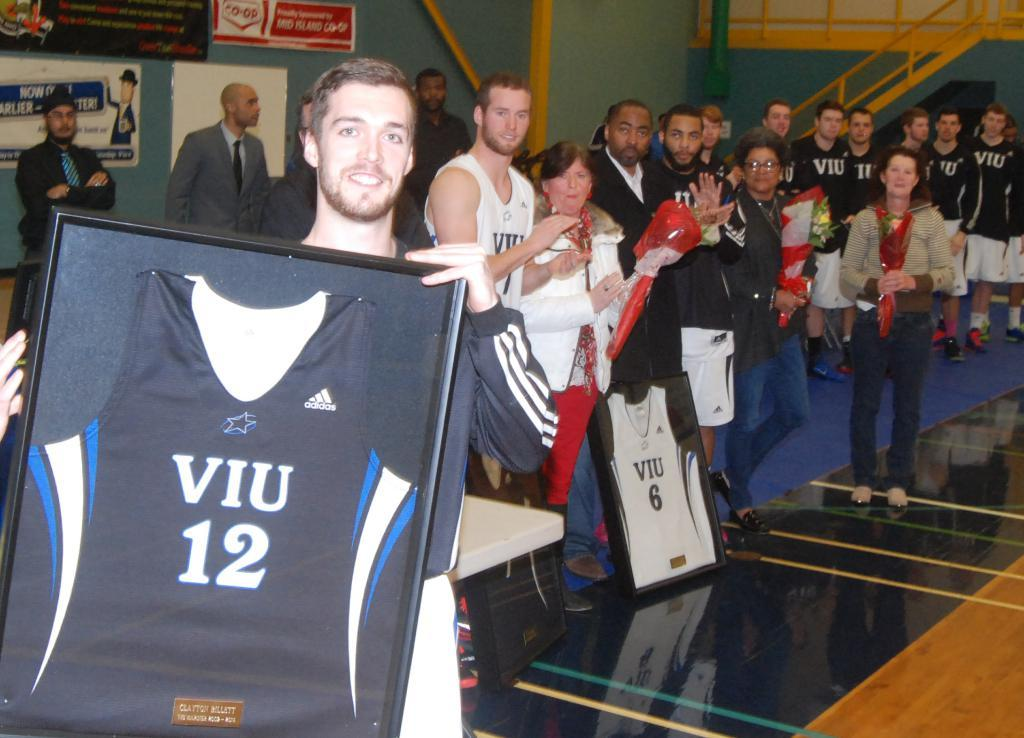<image>
Describe the image concisely. the number 12 that is on a viu jersey 